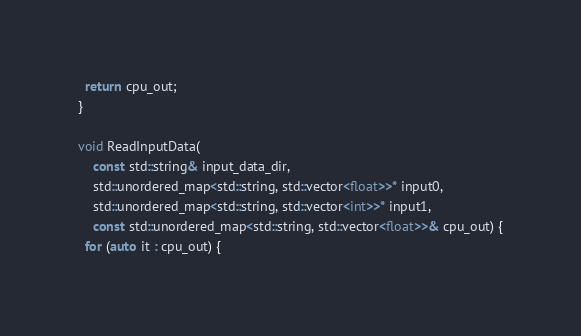<code> <loc_0><loc_0><loc_500><loc_500><_C++_>  return cpu_out;
}

void ReadInputData(
    const std::string& input_data_dir,
    std::unordered_map<std::string, std::vector<float>>* input0,
    std::unordered_map<std::string, std::vector<int>>* input1,
    const std::unordered_map<std::string, std::vector<float>>& cpu_out) {
  for (auto it : cpu_out) {</code> 